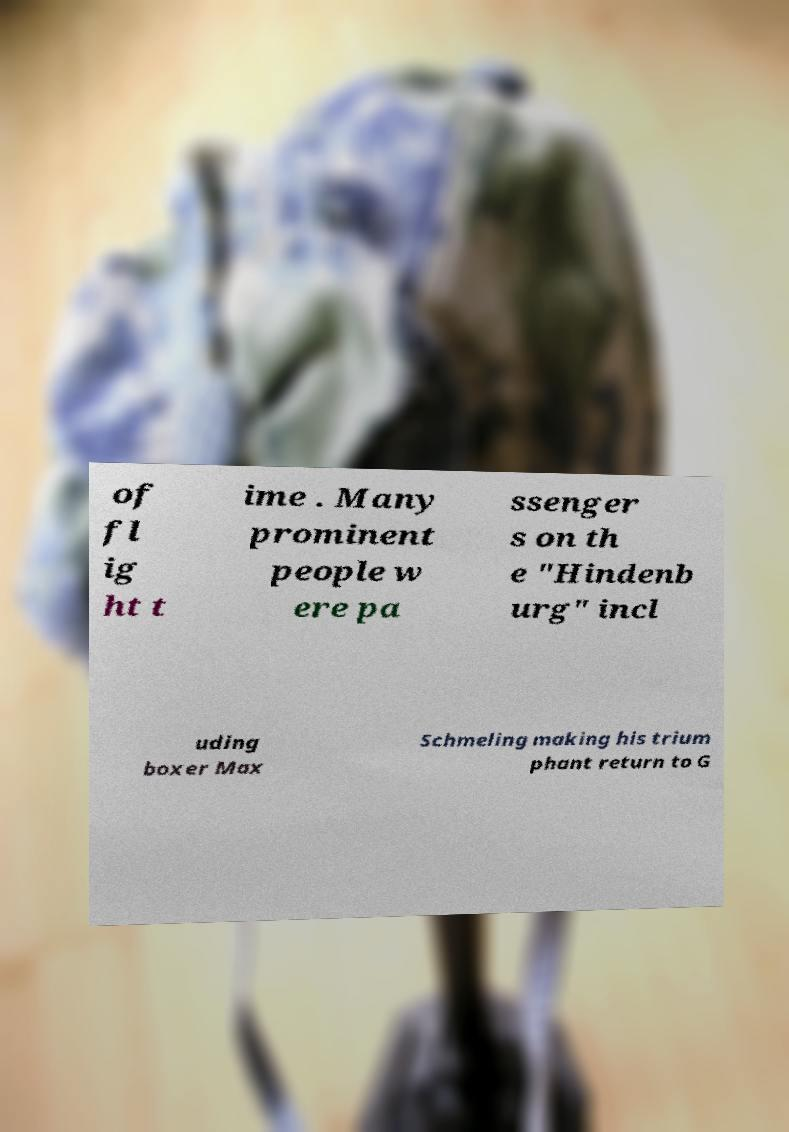For documentation purposes, I need the text within this image transcribed. Could you provide that? of fl ig ht t ime . Many prominent people w ere pa ssenger s on th e "Hindenb urg" incl uding boxer Max Schmeling making his trium phant return to G 